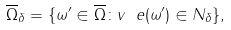Convert formula to latex. <formula><loc_0><loc_0><loc_500><loc_500>\overline { \Omega } _ { \delta } = \{ \omega ^ { \prime } \in \overline { \Omega } \colon v _ { \ } e ( \omega ^ { \prime } ) \in N _ { \delta } \} ,</formula> 